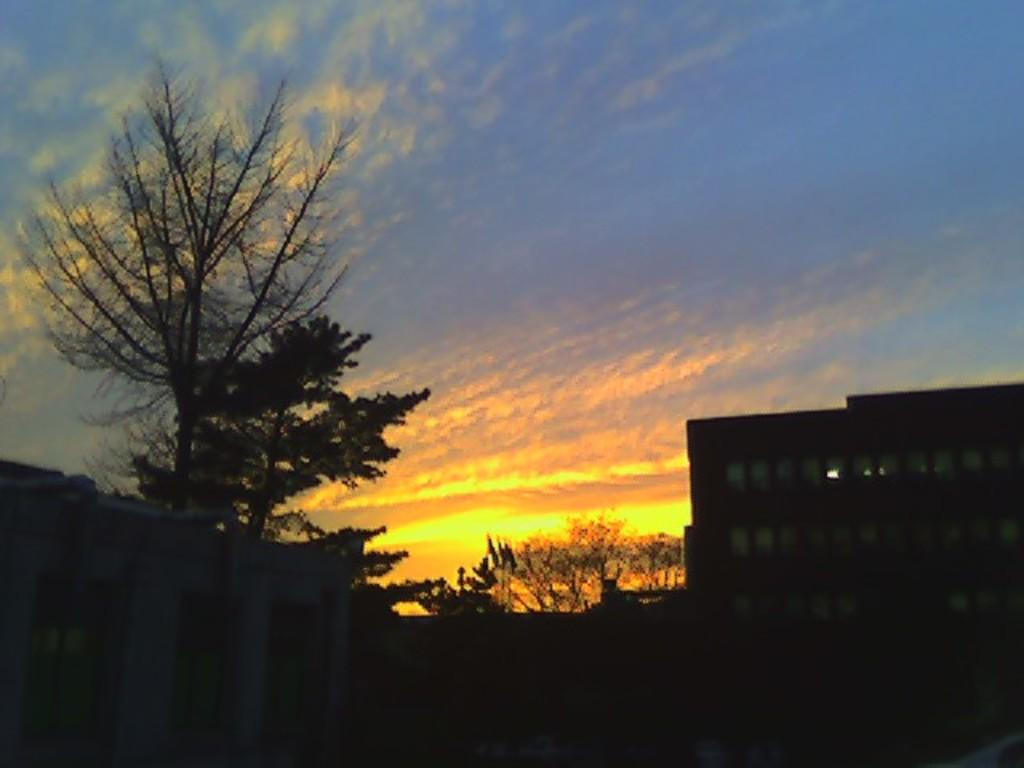Where was the picture taken? The picture was clicked outside. What can be seen on the left side of the image? There is a building and trees on the left side of the image. What can be seen on the right side of the image? There is a building on the right side of the image. What is visible in the background of the image? The sky and trees are visible in the background of the image. What type of cracker is being used to break the cup in the image? There is no cracker or cup present in the image. Can you tell me how many fangs are visible on the trees in the image? Trees do not have fangs, so this question cannot be answered based on the information provided. 